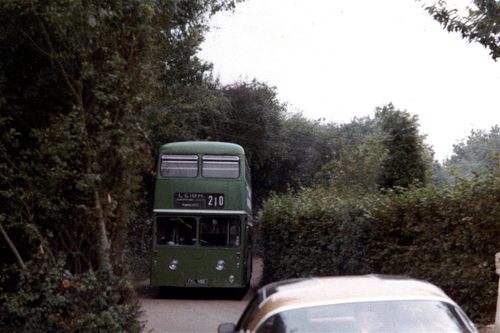Identify and read out the text in this image. 210 